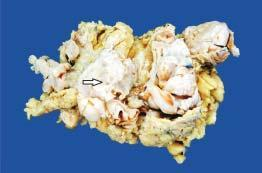what shows replacement of almost whole breast with a large circumscribed, greywhite, firm, nodular mass having slit-like, compressed cystic areas and areas of haemorrhage?
Answer the question using a single word or phrase. Simple mastectomy specimen 